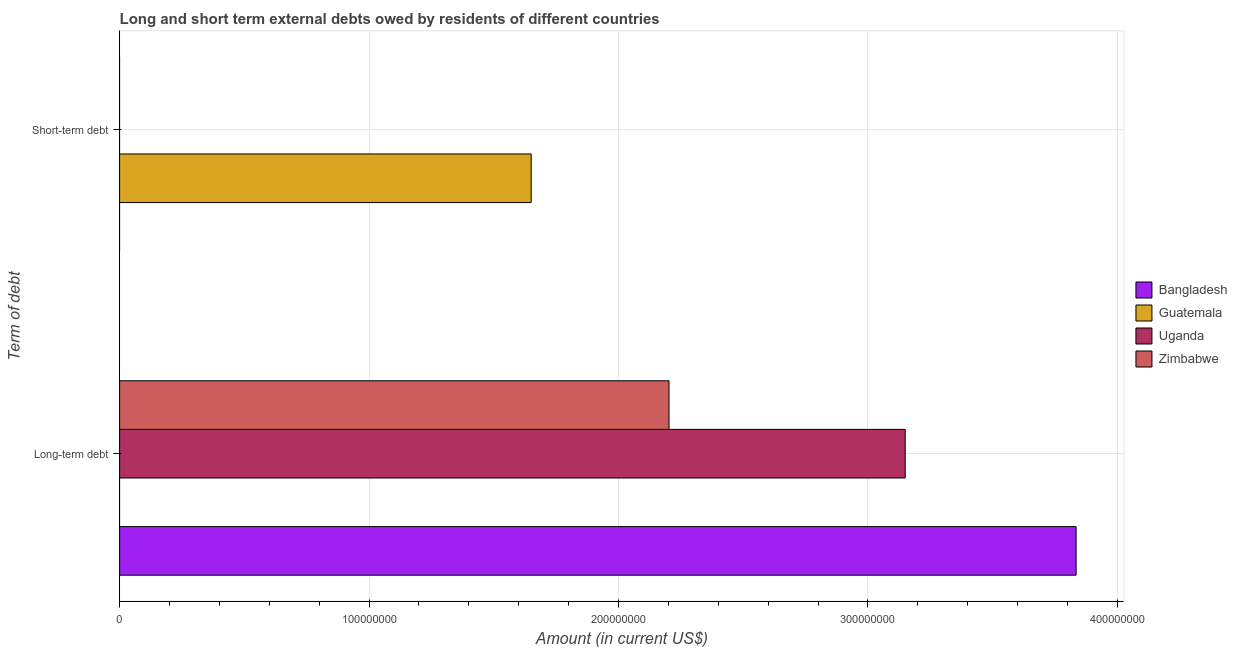Are the number of bars on each tick of the Y-axis equal?
Provide a succinct answer. No. How many bars are there on the 2nd tick from the top?
Keep it short and to the point. 3. How many bars are there on the 1st tick from the bottom?
Your answer should be very brief. 3. What is the label of the 2nd group of bars from the top?
Provide a succinct answer. Long-term debt. What is the long-term debts owed by residents in Guatemala?
Keep it short and to the point. 0. Across all countries, what is the maximum short-term debts owed by residents?
Provide a succinct answer. 1.65e+08. What is the total long-term debts owed by residents in the graph?
Provide a short and direct response. 9.19e+08. What is the difference between the long-term debts owed by residents in Uganda and that in Zimbabwe?
Make the answer very short. 9.47e+07. What is the difference between the short-term debts owed by residents in Guatemala and the long-term debts owed by residents in Uganda?
Your answer should be compact. -1.50e+08. What is the average short-term debts owed by residents per country?
Your answer should be very brief. 4.12e+07. In how many countries, is the long-term debts owed by residents greater than 300000000 US$?
Your answer should be very brief. 2. What is the ratio of the long-term debts owed by residents in Zimbabwe to that in Bangladesh?
Your answer should be compact. 0.57. How many bars are there?
Keep it short and to the point. 4. Are all the bars in the graph horizontal?
Ensure brevity in your answer.  Yes. How many countries are there in the graph?
Provide a short and direct response. 4. Are the values on the major ticks of X-axis written in scientific E-notation?
Ensure brevity in your answer.  No. Does the graph contain grids?
Your answer should be compact. Yes. Where does the legend appear in the graph?
Keep it short and to the point. Center right. How many legend labels are there?
Your answer should be compact. 4. How are the legend labels stacked?
Your answer should be very brief. Vertical. What is the title of the graph?
Your answer should be very brief. Long and short term external debts owed by residents of different countries. Does "Syrian Arab Republic" appear as one of the legend labels in the graph?
Make the answer very short. No. What is the label or title of the Y-axis?
Your answer should be compact. Term of debt. What is the Amount (in current US$) in Bangladesh in Long-term debt?
Make the answer very short. 3.83e+08. What is the Amount (in current US$) in Guatemala in Long-term debt?
Make the answer very short. 0. What is the Amount (in current US$) of Uganda in Long-term debt?
Provide a short and direct response. 3.15e+08. What is the Amount (in current US$) of Zimbabwe in Long-term debt?
Provide a succinct answer. 2.20e+08. What is the Amount (in current US$) of Guatemala in Short-term debt?
Ensure brevity in your answer.  1.65e+08. What is the Amount (in current US$) in Uganda in Short-term debt?
Give a very brief answer. 0. Across all Term of debt, what is the maximum Amount (in current US$) in Bangladesh?
Your answer should be very brief. 3.83e+08. Across all Term of debt, what is the maximum Amount (in current US$) in Guatemala?
Offer a very short reply. 1.65e+08. Across all Term of debt, what is the maximum Amount (in current US$) in Uganda?
Offer a very short reply. 3.15e+08. Across all Term of debt, what is the maximum Amount (in current US$) in Zimbabwe?
Your response must be concise. 2.20e+08. Across all Term of debt, what is the minimum Amount (in current US$) in Uganda?
Offer a very short reply. 0. What is the total Amount (in current US$) in Bangladesh in the graph?
Make the answer very short. 3.83e+08. What is the total Amount (in current US$) of Guatemala in the graph?
Give a very brief answer. 1.65e+08. What is the total Amount (in current US$) of Uganda in the graph?
Your answer should be very brief. 3.15e+08. What is the total Amount (in current US$) in Zimbabwe in the graph?
Offer a terse response. 2.20e+08. What is the difference between the Amount (in current US$) of Bangladesh in Long-term debt and the Amount (in current US$) of Guatemala in Short-term debt?
Make the answer very short. 2.18e+08. What is the average Amount (in current US$) of Bangladesh per Term of debt?
Offer a terse response. 1.92e+08. What is the average Amount (in current US$) in Guatemala per Term of debt?
Your response must be concise. 8.25e+07. What is the average Amount (in current US$) of Uganda per Term of debt?
Offer a terse response. 1.57e+08. What is the average Amount (in current US$) of Zimbabwe per Term of debt?
Make the answer very short. 1.10e+08. What is the difference between the Amount (in current US$) in Bangladesh and Amount (in current US$) in Uganda in Long-term debt?
Offer a very short reply. 6.85e+07. What is the difference between the Amount (in current US$) in Bangladesh and Amount (in current US$) in Zimbabwe in Long-term debt?
Your answer should be compact. 1.63e+08. What is the difference between the Amount (in current US$) of Uganda and Amount (in current US$) of Zimbabwe in Long-term debt?
Give a very brief answer. 9.47e+07. What is the difference between the highest and the lowest Amount (in current US$) in Bangladesh?
Make the answer very short. 3.83e+08. What is the difference between the highest and the lowest Amount (in current US$) in Guatemala?
Make the answer very short. 1.65e+08. What is the difference between the highest and the lowest Amount (in current US$) in Uganda?
Provide a short and direct response. 3.15e+08. What is the difference between the highest and the lowest Amount (in current US$) of Zimbabwe?
Offer a terse response. 2.20e+08. 